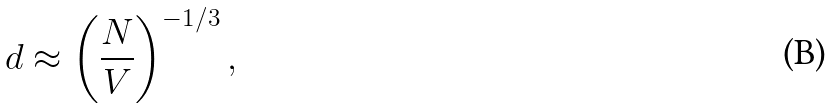<formula> <loc_0><loc_0><loc_500><loc_500>d \approx \left ( \frac { N } { V } \right ) ^ { - 1 / 3 } ,</formula> 